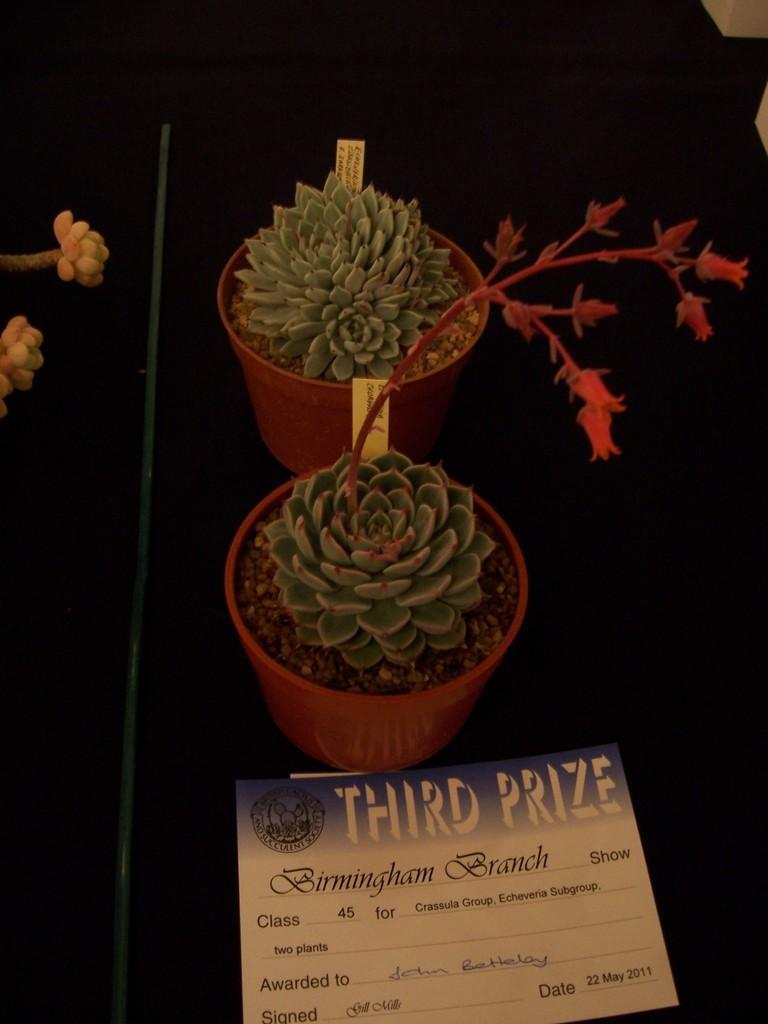Can you describe this image briefly? In this image we can see the potted plants, pole and a poster with some text and also we can see the background is dark. 